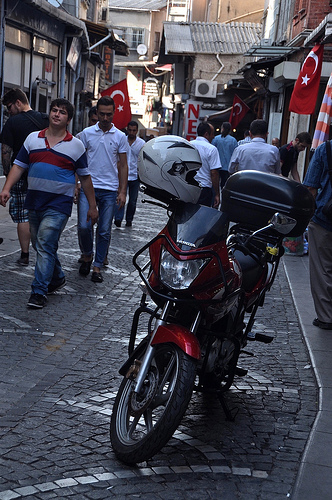<image>
Is the man behind the flag? No. The man is not behind the flag. From this viewpoint, the man appears to be positioned elsewhere in the scene. Is the flag above the person? No. The flag is not positioned above the person. The vertical arrangement shows a different relationship. 